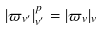Convert formula to latex. <formula><loc_0><loc_0><loc_500><loc_500>| \varpi _ { v ^ { \prime } } | ^ { p } _ { v ^ { \prime } } = | \varpi _ { v } | _ { v }</formula> 